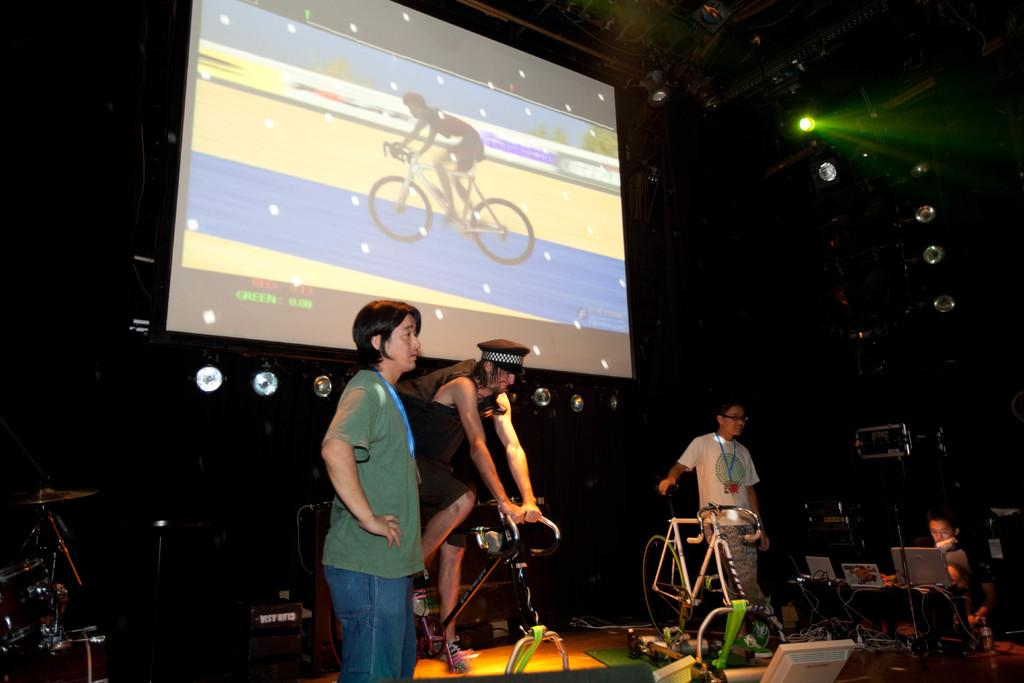How many people are in the image? There are four members in the image. What is one of the members doing in the image? One of the members is cycling a bicycle. What can be seen in the middle of the image? There is a screen in the middle of the image. What is the color of the background in the image? The background of the image is dark. What type of stocking is the donkey wearing in the image? There is no donkey or stocking present in the image. 